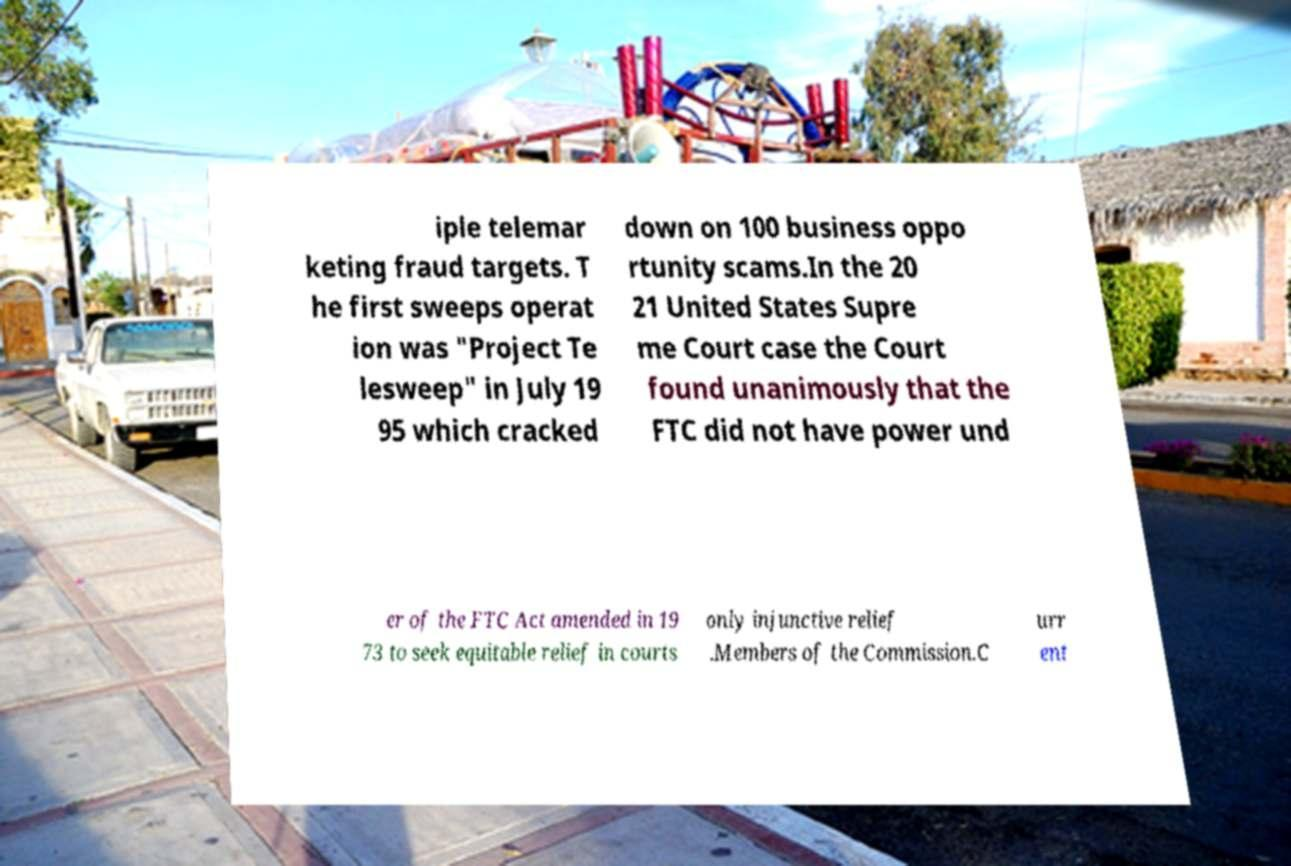There's text embedded in this image that I need extracted. Can you transcribe it verbatim? iple telemar keting fraud targets. T he first sweeps operat ion was "Project Te lesweep" in July 19 95 which cracked down on 100 business oppo rtunity scams.In the 20 21 United States Supre me Court case the Court found unanimously that the FTC did not have power und er of the FTC Act amended in 19 73 to seek equitable relief in courts only injunctive relief .Members of the Commission.C urr ent 